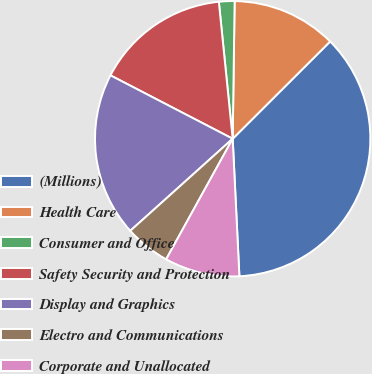Convert chart. <chart><loc_0><loc_0><loc_500><loc_500><pie_chart><fcel>(Millions)<fcel>Health Care<fcel>Consumer and Office<fcel>Safety Security and Protection<fcel>Display and Graphics<fcel>Electro and Communications<fcel>Corporate and Unallocated<nl><fcel>36.71%<fcel>12.29%<fcel>1.83%<fcel>15.78%<fcel>19.27%<fcel>5.32%<fcel>8.8%<nl></chart> 